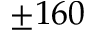Convert formula to latex. <formula><loc_0><loc_0><loc_500><loc_500>\pm 1 6 0</formula> 